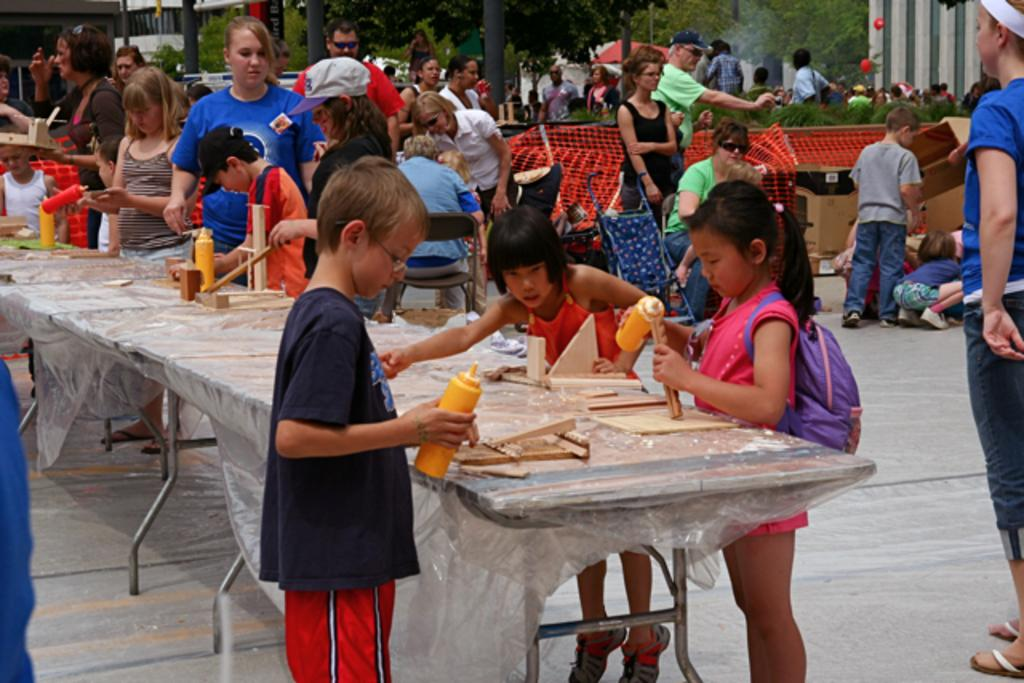How many groups of people are visible in the image? There are two groups of people visible in the image. What is in front of the first group of people? There is a table in front of the first group of people. What is on the table? The table has wooden blocks on it. What can be seen in the background of the image? Trees are present in the background of the image. What type of toys are being used in the competition in the image? There is no competition or toys present in the image; it features two groups of people and a table with wooden blocks. How does the sleet affect the people in the image? There is no sleet present in the image; the weather appears to be clear, as indicated by the trees in the background. 